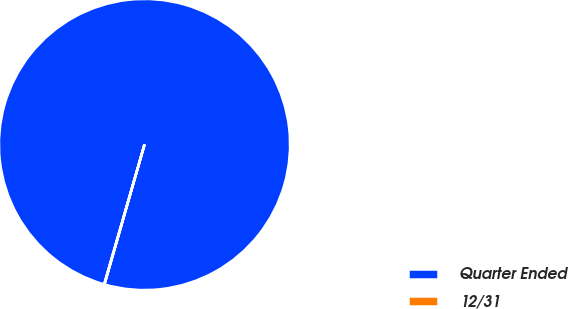Convert chart to OTSL. <chart><loc_0><loc_0><loc_500><loc_500><pie_chart><fcel>Quarter Ended<fcel>12/31<nl><fcel>99.96%<fcel>0.04%<nl></chart> 